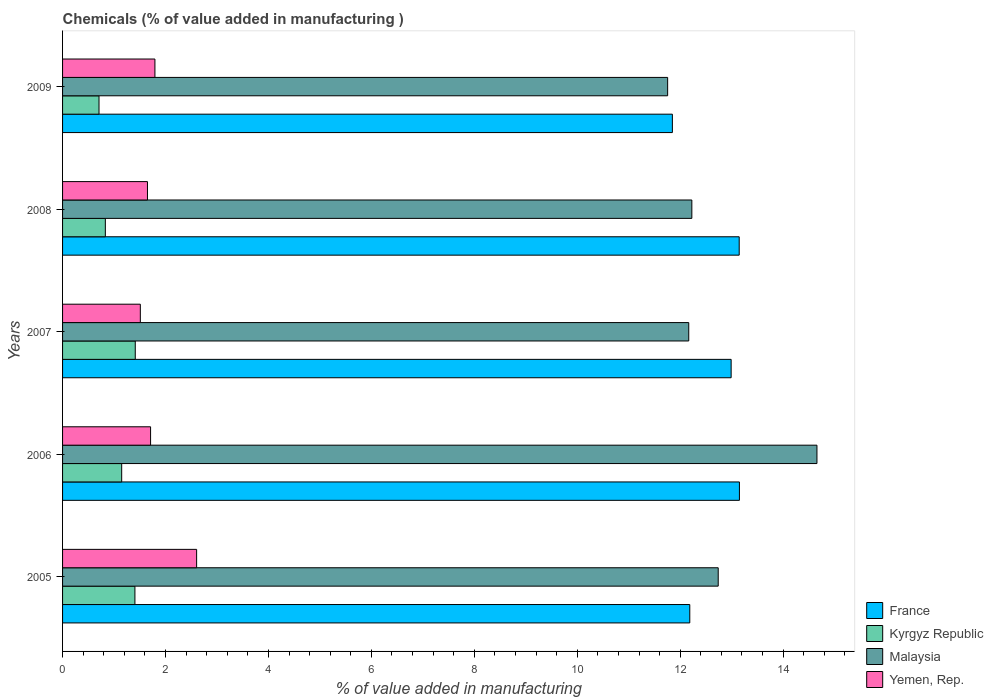How many groups of bars are there?
Your answer should be very brief. 5. Are the number of bars per tick equal to the number of legend labels?
Your answer should be very brief. Yes. Are the number of bars on each tick of the Y-axis equal?
Offer a terse response. Yes. How many bars are there on the 2nd tick from the top?
Keep it short and to the point. 4. How many bars are there on the 4th tick from the bottom?
Provide a short and direct response. 4. In how many cases, is the number of bars for a given year not equal to the number of legend labels?
Offer a terse response. 0. What is the value added in manufacturing chemicals in Kyrgyz Republic in 2007?
Keep it short and to the point. 1.41. Across all years, what is the maximum value added in manufacturing chemicals in Yemen, Rep.?
Offer a terse response. 2.6. Across all years, what is the minimum value added in manufacturing chemicals in France?
Provide a short and direct response. 11.85. In which year was the value added in manufacturing chemicals in Malaysia maximum?
Provide a succinct answer. 2006. In which year was the value added in manufacturing chemicals in Malaysia minimum?
Make the answer very short. 2009. What is the total value added in manufacturing chemicals in Yemen, Rep. in the graph?
Ensure brevity in your answer.  9.27. What is the difference between the value added in manufacturing chemicals in Yemen, Rep. in 2006 and that in 2009?
Provide a short and direct response. -0.08. What is the difference between the value added in manufacturing chemicals in Kyrgyz Republic in 2006 and the value added in manufacturing chemicals in Malaysia in 2005?
Your response must be concise. -11.59. What is the average value added in manufacturing chemicals in Malaysia per year?
Provide a short and direct response. 12.71. In the year 2005, what is the difference between the value added in manufacturing chemicals in France and value added in manufacturing chemicals in Malaysia?
Provide a succinct answer. -0.55. In how many years, is the value added in manufacturing chemicals in France greater than 4.4 %?
Make the answer very short. 5. What is the ratio of the value added in manufacturing chemicals in Kyrgyz Republic in 2006 to that in 2007?
Keep it short and to the point. 0.81. What is the difference between the highest and the second highest value added in manufacturing chemicals in Kyrgyz Republic?
Provide a short and direct response. 0.01. What is the difference between the highest and the lowest value added in manufacturing chemicals in Kyrgyz Republic?
Provide a short and direct response. 0.7. What does the 4th bar from the top in 2007 represents?
Keep it short and to the point. France. What does the 2nd bar from the bottom in 2005 represents?
Provide a short and direct response. Kyrgyz Republic. Is it the case that in every year, the sum of the value added in manufacturing chemicals in France and value added in manufacturing chemicals in Yemen, Rep. is greater than the value added in manufacturing chemicals in Malaysia?
Ensure brevity in your answer.  Yes. Are all the bars in the graph horizontal?
Make the answer very short. Yes. How many years are there in the graph?
Provide a short and direct response. 5. What is the difference between two consecutive major ticks on the X-axis?
Your answer should be very brief. 2. Are the values on the major ticks of X-axis written in scientific E-notation?
Make the answer very short. No. Does the graph contain grids?
Offer a very short reply. No. What is the title of the graph?
Make the answer very short. Chemicals (% of value added in manufacturing ). Does "Brunei Darussalam" appear as one of the legend labels in the graph?
Provide a succinct answer. No. What is the label or title of the X-axis?
Your response must be concise. % of value added in manufacturing. What is the label or title of the Y-axis?
Offer a very short reply. Years. What is the % of value added in manufacturing in France in 2005?
Keep it short and to the point. 12.19. What is the % of value added in manufacturing of Kyrgyz Republic in 2005?
Ensure brevity in your answer.  1.41. What is the % of value added in manufacturing in Malaysia in 2005?
Provide a short and direct response. 12.74. What is the % of value added in manufacturing in Yemen, Rep. in 2005?
Provide a short and direct response. 2.6. What is the % of value added in manufacturing in France in 2006?
Give a very brief answer. 13.15. What is the % of value added in manufacturing of Kyrgyz Republic in 2006?
Give a very brief answer. 1.15. What is the % of value added in manufacturing in Malaysia in 2006?
Ensure brevity in your answer.  14.66. What is the % of value added in manufacturing in Yemen, Rep. in 2006?
Give a very brief answer. 1.71. What is the % of value added in manufacturing of France in 2007?
Keep it short and to the point. 12.99. What is the % of value added in manufacturing of Kyrgyz Republic in 2007?
Provide a succinct answer. 1.41. What is the % of value added in manufacturing of Malaysia in 2007?
Give a very brief answer. 12.17. What is the % of value added in manufacturing in Yemen, Rep. in 2007?
Keep it short and to the point. 1.51. What is the % of value added in manufacturing in France in 2008?
Your answer should be very brief. 13.15. What is the % of value added in manufacturing in Kyrgyz Republic in 2008?
Ensure brevity in your answer.  0.83. What is the % of value added in manufacturing in Malaysia in 2008?
Your answer should be compact. 12.23. What is the % of value added in manufacturing of Yemen, Rep. in 2008?
Your answer should be very brief. 1.65. What is the % of value added in manufacturing in France in 2009?
Offer a very short reply. 11.85. What is the % of value added in manufacturing in Kyrgyz Republic in 2009?
Make the answer very short. 0.71. What is the % of value added in manufacturing in Malaysia in 2009?
Provide a succinct answer. 11.76. What is the % of value added in manufacturing in Yemen, Rep. in 2009?
Provide a short and direct response. 1.79. Across all years, what is the maximum % of value added in manufacturing in France?
Keep it short and to the point. 13.15. Across all years, what is the maximum % of value added in manufacturing in Kyrgyz Republic?
Make the answer very short. 1.41. Across all years, what is the maximum % of value added in manufacturing in Malaysia?
Your answer should be compact. 14.66. Across all years, what is the maximum % of value added in manufacturing of Yemen, Rep.?
Give a very brief answer. 2.6. Across all years, what is the minimum % of value added in manufacturing of France?
Provide a succinct answer. 11.85. Across all years, what is the minimum % of value added in manufacturing in Kyrgyz Republic?
Your answer should be very brief. 0.71. Across all years, what is the minimum % of value added in manufacturing of Malaysia?
Provide a succinct answer. 11.76. Across all years, what is the minimum % of value added in manufacturing in Yemen, Rep.?
Keep it short and to the point. 1.51. What is the total % of value added in manufacturing in France in the graph?
Ensure brevity in your answer.  63.32. What is the total % of value added in manufacturing of Kyrgyz Republic in the graph?
Your answer should be very brief. 5.51. What is the total % of value added in manufacturing in Malaysia in the graph?
Your answer should be very brief. 63.54. What is the total % of value added in manufacturing in Yemen, Rep. in the graph?
Offer a very short reply. 9.27. What is the difference between the % of value added in manufacturing of France in 2005 and that in 2006?
Your answer should be very brief. -0.96. What is the difference between the % of value added in manufacturing of Kyrgyz Republic in 2005 and that in 2006?
Your answer should be compact. 0.26. What is the difference between the % of value added in manufacturing of Malaysia in 2005 and that in 2006?
Make the answer very short. -1.92. What is the difference between the % of value added in manufacturing in Yemen, Rep. in 2005 and that in 2006?
Provide a short and direct response. 0.89. What is the difference between the % of value added in manufacturing of France in 2005 and that in 2007?
Give a very brief answer. -0.8. What is the difference between the % of value added in manufacturing of Kyrgyz Republic in 2005 and that in 2007?
Your answer should be compact. -0.01. What is the difference between the % of value added in manufacturing of Malaysia in 2005 and that in 2007?
Give a very brief answer. 0.57. What is the difference between the % of value added in manufacturing of Yemen, Rep. in 2005 and that in 2007?
Provide a succinct answer. 1.09. What is the difference between the % of value added in manufacturing in France in 2005 and that in 2008?
Give a very brief answer. -0.96. What is the difference between the % of value added in manufacturing of Kyrgyz Republic in 2005 and that in 2008?
Your answer should be very brief. 0.57. What is the difference between the % of value added in manufacturing of Malaysia in 2005 and that in 2008?
Ensure brevity in your answer.  0.51. What is the difference between the % of value added in manufacturing of Yemen, Rep. in 2005 and that in 2008?
Ensure brevity in your answer.  0.96. What is the difference between the % of value added in manufacturing of France in 2005 and that in 2009?
Your response must be concise. 0.34. What is the difference between the % of value added in manufacturing of Kyrgyz Republic in 2005 and that in 2009?
Your answer should be very brief. 0.7. What is the difference between the % of value added in manufacturing of Malaysia in 2005 and that in 2009?
Make the answer very short. 0.98. What is the difference between the % of value added in manufacturing in Yemen, Rep. in 2005 and that in 2009?
Your answer should be very brief. 0.81. What is the difference between the % of value added in manufacturing in France in 2006 and that in 2007?
Give a very brief answer. 0.16. What is the difference between the % of value added in manufacturing in Kyrgyz Republic in 2006 and that in 2007?
Provide a short and direct response. -0.26. What is the difference between the % of value added in manufacturing in Malaysia in 2006 and that in 2007?
Offer a very short reply. 2.49. What is the difference between the % of value added in manufacturing of Yemen, Rep. in 2006 and that in 2007?
Ensure brevity in your answer.  0.2. What is the difference between the % of value added in manufacturing of France in 2006 and that in 2008?
Offer a terse response. 0. What is the difference between the % of value added in manufacturing of Kyrgyz Republic in 2006 and that in 2008?
Offer a very short reply. 0.32. What is the difference between the % of value added in manufacturing in Malaysia in 2006 and that in 2008?
Make the answer very short. 2.43. What is the difference between the % of value added in manufacturing of Yemen, Rep. in 2006 and that in 2008?
Your answer should be compact. 0.06. What is the difference between the % of value added in manufacturing in France in 2006 and that in 2009?
Keep it short and to the point. 1.3. What is the difference between the % of value added in manufacturing of Kyrgyz Republic in 2006 and that in 2009?
Your response must be concise. 0.44. What is the difference between the % of value added in manufacturing in Malaysia in 2006 and that in 2009?
Offer a very short reply. 2.9. What is the difference between the % of value added in manufacturing of Yemen, Rep. in 2006 and that in 2009?
Keep it short and to the point. -0.08. What is the difference between the % of value added in manufacturing of France in 2007 and that in 2008?
Provide a short and direct response. -0.16. What is the difference between the % of value added in manufacturing of Kyrgyz Republic in 2007 and that in 2008?
Keep it short and to the point. 0.58. What is the difference between the % of value added in manufacturing of Malaysia in 2007 and that in 2008?
Provide a succinct answer. -0.06. What is the difference between the % of value added in manufacturing of Yemen, Rep. in 2007 and that in 2008?
Provide a succinct answer. -0.14. What is the difference between the % of value added in manufacturing in France in 2007 and that in 2009?
Your answer should be very brief. 1.14. What is the difference between the % of value added in manufacturing of Kyrgyz Republic in 2007 and that in 2009?
Your answer should be very brief. 0.7. What is the difference between the % of value added in manufacturing of Malaysia in 2007 and that in 2009?
Your response must be concise. 0.41. What is the difference between the % of value added in manufacturing of Yemen, Rep. in 2007 and that in 2009?
Keep it short and to the point. -0.28. What is the difference between the % of value added in manufacturing of France in 2008 and that in 2009?
Offer a very short reply. 1.3. What is the difference between the % of value added in manufacturing in Kyrgyz Republic in 2008 and that in 2009?
Provide a short and direct response. 0.12. What is the difference between the % of value added in manufacturing in Malaysia in 2008 and that in 2009?
Offer a very short reply. 0.47. What is the difference between the % of value added in manufacturing of Yemen, Rep. in 2008 and that in 2009?
Offer a very short reply. -0.14. What is the difference between the % of value added in manufacturing in France in 2005 and the % of value added in manufacturing in Kyrgyz Republic in 2006?
Ensure brevity in your answer.  11.04. What is the difference between the % of value added in manufacturing in France in 2005 and the % of value added in manufacturing in Malaysia in 2006?
Provide a succinct answer. -2.47. What is the difference between the % of value added in manufacturing of France in 2005 and the % of value added in manufacturing of Yemen, Rep. in 2006?
Offer a terse response. 10.48. What is the difference between the % of value added in manufacturing of Kyrgyz Republic in 2005 and the % of value added in manufacturing of Malaysia in 2006?
Ensure brevity in your answer.  -13.25. What is the difference between the % of value added in manufacturing of Kyrgyz Republic in 2005 and the % of value added in manufacturing of Yemen, Rep. in 2006?
Provide a succinct answer. -0.3. What is the difference between the % of value added in manufacturing in Malaysia in 2005 and the % of value added in manufacturing in Yemen, Rep. in 2006?
Make the answer very short. 11.03. What is the difference between the % of value added in manufacturing in France in 2005 and the % of value added in manufacturing in Kyrgyz Republic in 2007?
Ensure brevity in your answer.  10.77. What is the difference between the % of value added in manufacturing in France in 2005 and the % of value added in manufacturing in Malaysia in 2007?
Keep it short and to the point. 0.02. What is the difference between the % of value added in manufacturing in France in 2005 and the % of value added in manufacturing in Yemen, Rep. in 2007?
Provide a short and direct response. 10.68. What is the difference between the % of value added in manufacturing in Kyrgyz Republic in 2005 and the % of value added in manufacturing in Malaysia in 2007?
Provide a short and direct response. -10.76. What is the difference between the % of value added in manufacturing in Kyrgyz Republic in 2005 and the % of value added in manufacturing in Yemen, Rep. in 2007?
Offer a terse response. -0.11. What is the difference between the % of value added in manufacturing in Malaysia in 2005 and the % of value added in manufacturing in Yemen, Rep. in 2007?
Give a very brief answer. 11.23. What is the difference between the % of value added in manufacturing in France in 2005 and the % of value added in manufacturing in Kyrgyz Republic in 2008?
Provide a short and direct response. 11.36. What is the difference between the % of value added in manufacturing in France in 2005 and the % of value added in manufacturing in Malaysia in 2008?
Make the answer very short. -0.04. What is the difference between the % of value added in manufacturing in France in 2005 and the % of value added in manufacturing in Yemen, Rep. in 2008?
Your response must be concise. 10.54. What is the difference between the % of value added in manufacturing in Kyrgyz Republic in 2005 and the % of value added in manufacturing in Malaysia in 2008?
Your response must be concise. -10.82. What is the difference between the % of value added in manufacturing of Kyrgyz Republic in 2005 and the % of value added in manufacturing of Yemen, Rep. in 2008?
Your answer should be very brief. -0.24. What is the difference between the % of value added in manufacturing in Malaysia in 2005 and the % of value added in manufacturing in Yemen, Rep. in 2008?
Provide a succinct answer. 11.09. What is the difference between the % of value added in manufacturing of France in 2005 and the % of value added in manufacturing of Kyrgyz Republic in 2009?
Give a very brief answer. 11.48. What is the difference between the % of value added in manufacturing of France in 2005 and the % of value added in manufacturing of Malaysia in 2009?
Provide a short and direct response. 0.43. What is the difference between the % of value added in manufacturing of France in 2005 and the % of value added in manufacturing of Yemen, Rep. in 2009?
Give a very brief answer. 10.39. What is the difference between the % of value added in manufacturing in Kyrgyz Republic in 2005 and the % of value added in manufacturing in Malaysia in 2009?
Provide a short and direct response. -10.35. What is the difference between the % of value added in manufacturing in Kyrgyz Republic in 2005 and the % of value added in manufacturing in Yemen, Rep. in 2009?
Provide a short and direct response. -0.39. What is the difference between the % of value added in manufacturing of Malaysia in 2005 and the % of value added in manufacturing of Yemen, Rep. in 2009?
Your answer should be very brief. 10.94. What is the difference between the % of value added in manufacturing in France in 2006 and the % of value added in manufacturing in Kyrgyz Republic in 2007?
Offer a terse response. 11.74. What is the difference between the % of value added in manufacturing in France in 2006 and the % of value added in manufacturing in Malaysia in 2007?
Provide a short and direct response. 0.98. What is the difference between the % of value added in manufacturing of France in 2006 and the % of value added in manufacturing of Yemen, Rep. in 2007?
Ensure brevity in your answer.  11.64. What is the difference between the % of value added in manufacturing in Kyrgyz Republic in 2006 and the % of value added in manufacturing in Malaysia in 2007?
Provide a short and direct response. -11.02. What is the difference between the % of value added in manufacturing in Kyrgyz Republic in 2006 and the % of value added in manufacturing in Yemen, Rep. in 2007?
Provide a short and direct response. -0.36. What is the difference between the % of value added in manufacturing of Malaysia in 2006 and the % of value added in manufacturing of Yemen, Rep. in 2007?
Your answer should be compact. 13.15. What is the difference between the % of value added in manufacturing in France in 2006 and the % of value added in manufacturing in Kyrgyz Republic in 2008?
Your answer should be very brief. 12.32. What is the difference between the % of value added in manufacturing of France in 2006 and the % of value added in manufacturing of Malaysia in 2008?
Offer a terse response. 0.92. What is the difference between the % of value added in manufacturing in France in 2006 and the % of value added in manufacturing in Yemen, Rep. in 2008?
Provide a succinct answer. 11.5. What is the difference between the % of value added in manufacturing of Kyrgyz Republic in 2006 and the % of value added in manufacturing of Malaysia in 2008?
Provide a short and direct response. -11.08. What is the difference between the % of value added in manufacturing in Kyrgyz Republic in 2006 and the % of value added in manufacturing in Yemen, Rep. in 2008?
Give a very brief answer. -0.5. What is the difference between the % of value added in manufacturing of Malaysia in 2006 and the % of value added in manufacturing of Yemen, Rep. in 2008?
Offer a very short reply. 13.01. What is the difference between the % of value added in manufacturing in France in 2006 and the % of value added in manufacturing in Kyrgyz Republic in 2009?
Provide a succinct answer. 12.44. What is the difference between the % of value added in manufacturing in France in 2006 and the % of value added in manufacturing in Malaysia in 2009?
Your answer should be very brief. 1.39. What is the difference between the % of value added in manufacturing of France in 2006 and the % of value added in manufacturing of Yemen, Rep. in 2009?
Provide a short and direct response. 11.36. What is the difference between the % of value added in manufacturing in Kyrgyz Republic in 2006 and the % of value added in manufacturing in Malaysia in 2009?
Provide a succinct answer. -10.61. What is the difference between the % of value added in manufacturing in Kyrgyz Republic in 2006 and the % of value added in manufacturing in Yemen, Rep. in 2009?
Offer a terse response. -0.65. What is the difference between the % of value added in manufacturing of Malaysia in 2006 and the % of value added in manufacturing of Yemen, Rep. in 2009?
Your answer should be very brief. 12.86. What is the difference between the % of value added in manufacturing in France in 2007 and the % of value added in manufacturing in Kyrgyz Republic in 2008?
Ensure brevity in your answer.  12.16. What is the difference between the % of value added in manufacturing of France in 2007 and the % of value added in manufacturing of Malaysia in 2008?
Ensure brevity in your answer.  0.76. What is the difference between the % of value added in manufacturing of France in 2007 and the % of value added in manufacturing of Yemen, Rep. in 2008?
Provide a short and direct response. 11.34. What is the difference between the % of value added in manufacturing of Kyrgyz Republic in 2007 and the % of value added in manufacturing of Malaysia in 2008?
Ensure brevity in your answer.  -10.81. What is the difference between the % of value added in manufacturing of Kyrgyz Republic in 2007 and the % of value added in manufacturing of Yemen, Rep. in 2008?
Your answer should be very brief. -0.24. What is the difference between the % of value added in manufacturing in Malaysia in 2007 and the % of value added in manufacturing in Yemen, Rep. in 2008?
Your answer should be very brief. 10.52. What is the difference between the % of value added in manufacturing of France in 2007 and the % of value added in manufacturing of Kyrgyz Republic in 2009?
Keep it short and to the point. 12.28. What is the difference between the % of value added in manufacturing of France in 2007 and the % of value added in manufacturing of Malaysia in 2009?
Your answer should be very brief. 1.23. What is the difference between the % of value added in manufacturing in France in 2007 and the % of value added in manufacturing in Yemen, Rep. in 2009?
Make the answer very short. 11.2. What is the difference between the % of value added in manufacturing of Kyrgyz Republic in 2007 and the % of value added in manufacturing of Malaysia in 2009?
Keep it short and to the point. -10.34. What is the difference between the % of value added in manufacturing in Kyrgyz Republic in 2007 and the % of value added in manufacturing in Yemen, Rep. in 2009?
Your answer should be very brief. -0.38. What is the difference between the % of value added in manufacturing in Malaysia in 2007 and the % of value added in manufacturing in Yemen, Rep. in 2009?
Provide a succinct answer. 10.37. What is the difference between the % of value added in manufacturing in France in 2008 and the % of value added in manufacturing in Kyrgyz Republic in 2009?
Give a very brief answer. 12.44. What is the difference between the % of value added in manufacturing in France in 2008 and the % of value added in manufacturing in Malaysia in 2009?
Provide a short and direct response. 1.39. What is the difference between the % of value added in manufacturing in France in 2008 and the % of value added in manufacturing in Yemen, Rep. in 2009?
Make the answer very short. 11.35. What is the difference between the % of value added in manufacturing in Kyrgyz Republic in 2008 and the % of value added in manufacturing in Malaysia in 2009?
Make the answer very short. -10.92. What is the difference between the % of value added in manufacturing in Kyrgyz Republic in 2008 and the % of value added in manufacturing in Yemen, Rep. in 2009?
Make the answer very short. -0.96. What is the difference between the % of value added in manufacturing in Malaysia in 2008 and the % of value added in manufacturing in Yemen, Rep. in 2009?
Provide a succinct answer. 10.43. What is the average % of value added in manufacturing in France per year?
Your answer should be compact. 12.66. What is the average % of value added in manufacturing of Kyrgyz Republic per year?
Provide a succinct answer. 1.1. What is the average % of value added in manufacturing in Malaysia per year?
Provide a short and direct response. 12.71. What is the average % of value added in manufacturing of Yemen, Rep. per year?
Ensure brevity in your answer.  1.85. In the year 2005, what is the difference between the % of value added in manufacturing in France and % of value added in manufacturing in Kyrgyz Republic?
Your answer should be compact. 10.78. In the year 2005, what is the difference between the % of value added in manufacturing in France and % of value added in manufacturing in Malaysia?
Provide a short and direct response. -0.55. In the year 2005, what is the difference between the % of value added in manufacturing of France and % of value added in manufacturing of Yemen, Rep.?
Provide a succinct answer. 9.58. In the year 2005, what is the difference between the % of value added in manufacturing in Kyrgyz Republic and % of value added in manufacturing in Malaysia?
Ensure brevity in your answer.  -11.33. In the year 2005, what is the difference between the % of value added in manufacturing of Kyrgyz Republic and % of value added in manufacturing of Yemen, Rep.?
Offer a very short reply. -1.2. In the year 2005, what is the difference between the % of value added in manufacturing in Malaysia and % of value added in manufacturing in Yemen, Rep.?
Ensure brevity in your answer.  10.13. In the year 2006, what is the difference between the % of value added in manufacturing in France and % of value added in manufacturing in Kyrgyz Republic?
Provide a succinct answer. 12. In the year 2006, what is the difference between the % of value added in manufacturing in France and % of value added in manufacturing in Malaysia?
Give a very brief answer. -1.51. In the year 2006, what is the difference between the % of value added in manufacturing in France and % of value added in manufacturing in Yemen, Rep.?
Keep it short and to the point. 11.44. In the year 2006, what is the difference between the % of value added in manufacturing in Kyrgyz Republic and % of value added in manufacturing in Malaysia?
Offer a very short reply. -13.51. In the year 2006, what is the difference between the % of value added in manufacturing of Kyrgyz Republic and % of value added in manufacturing of Yemen, Rep.?
Your answer should be very brief. -0.56. In the year 2006, what is the difference between the % of value added in manufacturing in Malaysia and % of value added in manufacturing in Yemen, Rep.?
Provide a succinct answer. 12.95. In the year 2007, what is the difference between the % of value added in manufacturing in France and % of value added in manufacturing in Kyrgyz Republic?
Your response must be concise. 11.58. In the year 2007, what is the difference between the % of value added in manufacturing in France and % of value added in manufacturing in Malaysia?
Provide a short and direct response. 0.82. In the year 2007, what is the difference between the % of value added in manufacturing of France and % of value added in manufacturing of Yemen, Rep.?
Keep it short and to the point. 11.48. In the year 2007, what is the difference between the % of value added in manufacturing in Kyrgyz Republic and % of value added in manufacturing in Malaysia?
Offer a very short reply. -10.75. In the year 2007, what is the difference between the % of value added in manufacturing of Kyrgyz Republic and % of value added in manufacturing of Yemen, Rep.?
Give a very brief answer. -0.1. In the year 2007, what is the difference between the % of value added in manufacturing of Malaysia and % of value added in manufacturing of Yemen, Rep.?
Your answer should be compact. 10.66. In the year 2008, what is the difference between the % of value added in manufacturing in France and % of value added in manufacturing in Kyrgyz Republic?
Keep it short and to the point. 12.31. In the year 2008, what is the difference between the % of value added in manufacturing of France and % of value added in manufacturing of Malaysia?
Provide a short and direct response. 0.92. In the year 2008, what is the difference between the % of value added in manufacturing of France and % of value added in manufacturing of Yemen, Rep.?
Your response must be concise. 11.5. In the year 2008, what is the difference between the % of value added in manufacturing of Kyrgyz Republic and % of value added in manufacturing of Malaysia?
Your answer should be very brief. -11.4. In the year 2008, what is the difference between the % of value added in manufacturing in Kyrgyz Republic and % of value added in manufacturing in Yemen, Rep.?
Offer a very short reply. -0.82. In the year 2008, what is the difference between the % of value added in manufacturing in Malaysia and % of value added in manufacturing in Yemen, Rep.?
Offer a terse response. 10.58. In the year 2009, what is the difference between the % of value added in manufacturing of France and % of value added in manufacturing of Kyrgyz Republic?
Offer a very short reply. 11.14. In the year 2009, what is the difference between the % of value added in manufacturing in France and % of value added in manufacturing in Malaysia?
Keep it short and to the point. 0.09. In the year 2009, what is the difference between the % of value added in manufacturing of France and % of value added in manufacturing of Yemen, Rep.?
Give a very brief answer. 10.05. In the year 2009, what is the difference between the % of value added in manufacturing of Kyrgyz Republic and % of value added in manufacturing of Malaysia?
Ensure brevity in your answer.  -11.05. In the year 2009, what is the difference between the % of value added in manufacturing of Kyrgyz Republic and % of value added in manufacturing of Yemen, Rep.?
Keep it short and to the point. -1.09. In the year 2009, what is the difference between the % of value added in manufacturing in Malaysia and % of value added in manufacturing in Yemen, Rep.?
Your response must be concise. 9.96. What is the ratio of the % of value added in manufacturing of France in 2005 to that in 2006?
Offer a terse response. 0.93. What is the ratio of the % of value added in manufacturing of Kyrgyz Republic in 2005 to that in 2006?
Offer a very short reply. 1.22. What is the ratio of the % of value added in manufacturing in Malaysia in 2005 to that in 2006?
Offer a very short reply. 0.87. What is the ratio of the % of value added in manufacturing of Yemen, Rep. in 2005 to that in 2006?
Give a very brief answer. 1.52. What is the ratio of the % of value added in manufacturing of France in 2005 to that in 2007?
Your answer should be compact. 0.94. What is the ratio of the % of value added in manufacturing of Kyrgyz Republic in 2005 to that in 2007?
Offer a terse response. 1. What is the ratio of the % of value added in manufacturing in Malaysia in 2005 to that in 2007?
Make the answer very short. 1.05. What is the ratio of the % of value added in manufacturing of Yemen, Rep. in 2005 to that in 2007?
Offer a terse response. 1.72. What is the ratio of the % of value added in manufacturing of France in 2005 to that in 2008?
Provide a short and direct response. 0.93. What is the ratio of the % of value added in manufacturing of Kyrgyz Republic in 2005 to that in 2008?
Your response must be concise. 1.69. What is the ratio of the % of value added in manufacturing in Malaysia in 2005 to that in 2008?
Keep it short and to the point. 1.04. What is the ratio of the % of value added in manufacturing in Yemen, Rep. in 2005 to that in 2008?
Offer a terse response. 1.58. What is the ratio of the % of value added in manufacturing of France in 2005 to that in 2009?
Give a very brief answer. 1.03. What is the ratio of the % of value added in manufacturing in Kyrgyz Republic in 2005 to that in 2009?
Offer a terse response. 1.99. What is the ratio of the % of value added in manufacturing of Malaysia in 2005 to that in 2009?
Ensure brevity in your answer.  1.08. What is the ratio of the % of value added in manufacturing in Yemen, Rep. in 2005 to that in 2009?
Your answer should be very brief. 1.45. What is the ratio of the % of value added in manufacturing of France in 2006 to that in 2007?
Ensure brevity in your answer.  1.01. What is the ratio of the % of value added in manufacturing of Kyrgyz Republic in 2006 to that in 2007?
Your answer should be compact. 0.81. What is the ratio of the % of value added in manufacturing of Malaysia in 2006 to that in 2007?
Offer a terse response. 1.2. What is the ratio of the % of value added in manufacturing in Yemen, Rep. in 2006 to that in 2007?
Ensure brevity in your answer.  1.13. What is the ratio of the % of value added in manufacturing of France in 2006 to that in 2008?
Provide a succinct answer. 1. What is the ratio of the % of value added in manufacturing of Kyrgyz Republic in 2006 to that in 2008?
Give a very brief answer. 1.38. What is the ratio of the % of value added in manufacturing of Malaysia in 2006 to that in 2008?
Your response must be concise. 1.2. What is the ratio of the % of value added in manufacturing of Yemen, Rep. in 2006 to that in 2008?
Offer a terse response. 1.04. What is the ratio of the % of value added in manufacturing of France in 2006 to that in 2009?
Ensure brevity in your answer.  1.11. What is the ratio of the % of value added in manufacturing in Kyrgyz Republic in 2006 to that in 2009?
Your answer should be compact. 1.62. What is the ratio of the % of value added in manufacturing in Malaysia in 2006 to that in 2009?
Give a very brief answer. 1.25. What is the ratio of the % of value added in manufacturing in Yemen, Rep. in 2006 to that in 2009?
Your answer should be compact. 0.95. What is the ratio of the % of value added in manufacturing in Kyrgyz Republic in 2007 to that in 2008?
Provide a short and direct response. 1.7. What is the ratio of the % of value added in manufacturing in Malaysia in 2007 to that in 2008?
Give a very brief answer. 1. What is the ratio of the % of value added in manufacturing of Yemen, Rep. in 2007 to that in 2008?
Provide a succinct answer. 0.92. What is the ratio of the % of value added in manufacturing of France in 2007 to that in 2009?
Your response must be concise. 1.1. What is the ratio of the % of value added in manufacturing of Kyrgyz Republic in 2007 to that in 2009?
Make the answer very short. 1.99. What is the ratio of the % of value added in manufacturing of Malaysia in 2007 to that in 2009?
Provide a short and direct response. 1.03. What is the ratio of the % of value added in manufacturing in Yemen, Rep. in 2007 to that in 2009?
Offer a very short reply. 0.84. What is the ratio of the % of value added in manufacturing of France in 2008 to that in 2009?
Your answer should be very brief. 1.11. What is the ratio of the % of value added in manufacturing in Kyrgyz Republic in 2008 to that in 2009?
Provide a succinct answer. 1.17. What is the ratio of the % of value added in manufacturing of Malaysia in 2008 to that in 2009?
Keep it short and to the point. 1.04. What is the ratio of the % of value added in manufacturing in Yemen, Rep. in 2008 to that in 2009?
Give a very brief answer. 0.92. What is the difference between the highest and the second highest % of value added in manufacturing in France?
Provide a short and direct response. 0. What is the difference between the highest and the second highest % of value added in manufacturing in Kyrgyz Republic?
Make the answer very short. 0.01. What is the difference between the highest and the second highest % of value added in manufacturing of Malaysia?
Your answer should be very brief. 1.92. What is the difference between the highest and the second highest % of value added in manufacturing in Yemen, Rep.?
Ensure brevity in your answer.  0.81. What is the difference between the highest and the lowest % of value added in manufacturing of France?
Your answer should be compact. 1.3. What is the difference between the highest and the lowest % of value added in manufacturing in Kyrgyz Republic?
Ensure brevity in your answer.  0.7. What is the difference between the highest and the lowest % of value added in manufacturing of Malaysia?
Make the answer very short. 2.9. What is the difference between the highest and the lowest % of value added in manufacturing in Yemen, Rep.?
Your response must be concise. 1.09. 